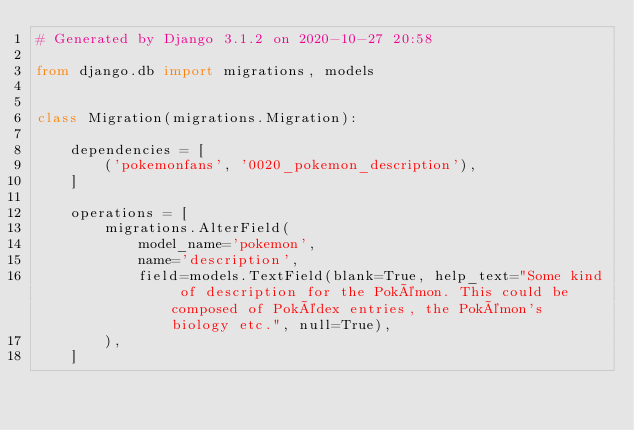Convert code to text. <code><loc_0><loc_0><loc_500><loc_500><_Python_># Generated by Django 3.1.2 on 2020-10-27 20:58

from django.db import migrations, models


class Migration(migrations.Migration):

    dependencies = [
        ('pokemonfans', '0020_pokemon_description'),
    ]

    operations = [
        migrations.AlterField(
            model_name='pokemon',
            name='description',
            field=models.TextField(blank=True, help_text="Some kind of description for the Pokémon. This could be composed of Pokédex entries, the Pokémon's biology etc.", null=True),
        ),
    ]
</code> 